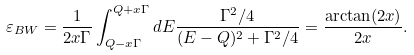Convert formula to latex. <formula><loc_0><loc_0><loc_500><loc_500>\varepsilon _ { B W } = \frac { 1 } { 2 x \Gamma } \int _ { Q - x \Gamma } ^ { Q + x \Gamma } d E \frac { \Gamma ^ { 2 } / 4 } { ( E - Q ) ^ { 2 } + \Gamma ^ { 2 } / 4 } = \frac { \arctan ( 2 x ) } { 2 x } .</formula> 